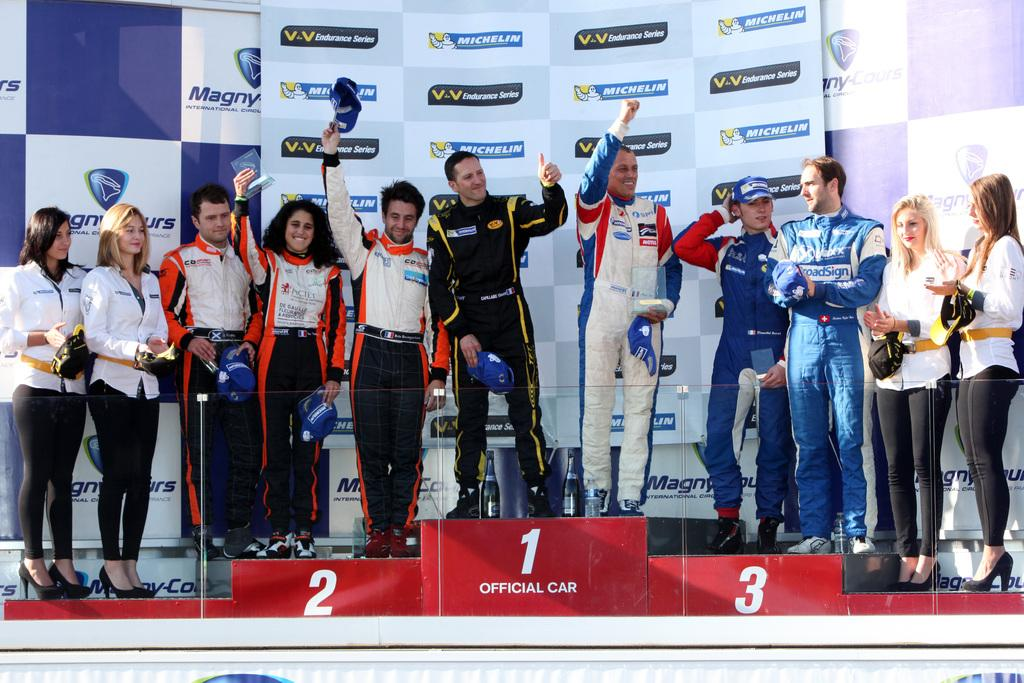<image>
Offer a succinct explanation of the picture presented. a group of people in uniform standing on a podium with sponsor of michelin on the wall behind them 